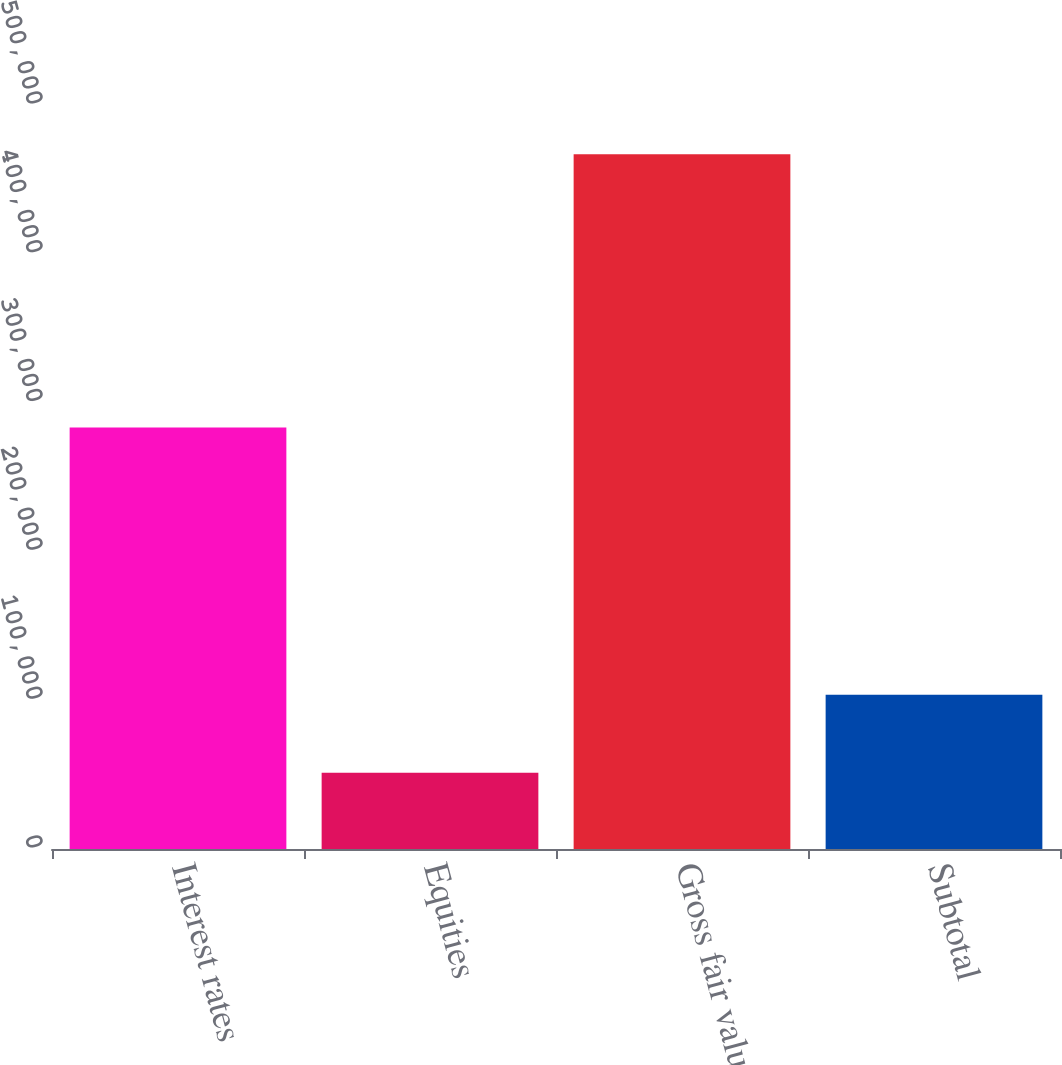<chart> <loc_0><loc_0><loc_500><loc_500><bar_chart><fcel>Interest rates<fcel>Equities<fcel>Gross fair value<fcel>Subtotal<nl><fcel>283262<fcel>51287<fcel>466863<fcel>103703<nl></chart> 